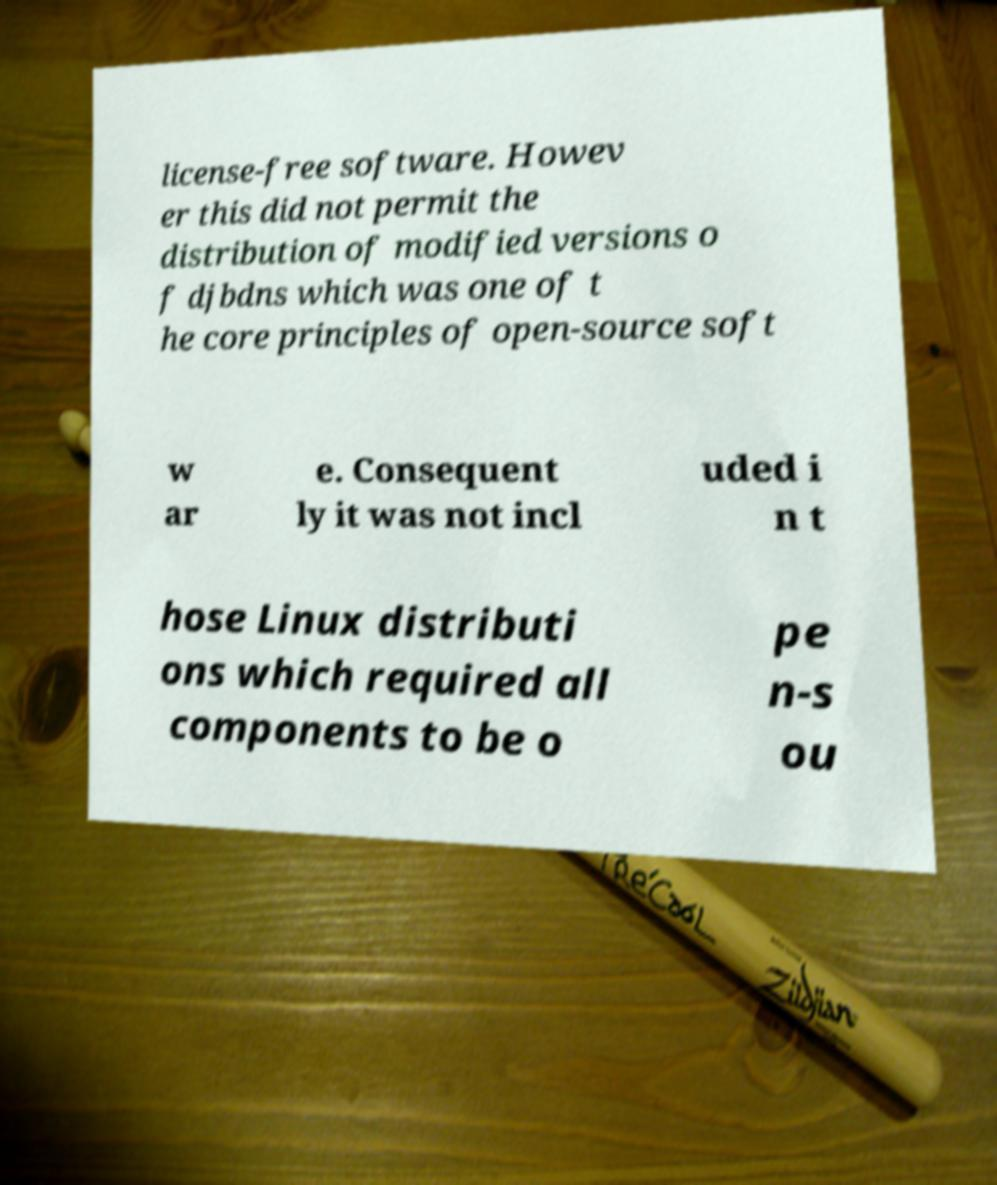Could you extract and type out the text from this image? license-free software. Howev er this did not permit the distribution of modified versions o f djbdns which was one of t he core principles of open-source soft w ar e. Consequent ly it was not incl uded i n t hose Linux distributi ons which required all components to be o pe n-s ou 